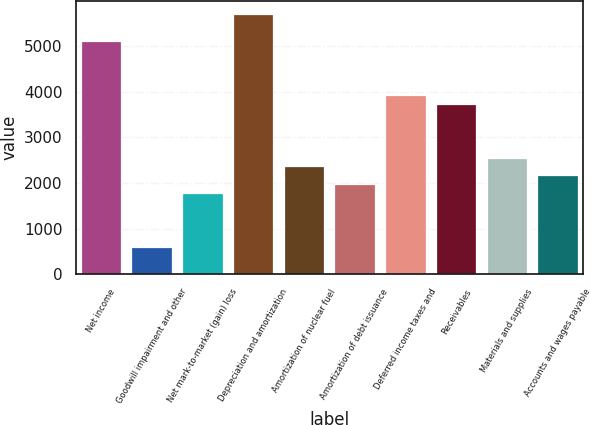<chart> <loc_0><loc_0><loc_500><loc_500><bar_chart><fcel>Net income<fcel>Goodwill impairment and other<fcel>Net mark-to-market (gain) loss<fcel>Depreciation and amortization<fcel>Amortization of nuclear fuel<fcel>Amortization of debt issuance<fcel>Deferred income taxes and<fcel>Receivables<fcel>Materials and supplies<fcel>Accounts and wages payable<nl><fcel>5112.6<fcel>590.8<fcel>1770.4<fcel>5702.4<fcel>2360.2<fcel>1967<fcel>3933<fcel>3736.4<fcel>2556.8<fcel>2163.6<nl></chart> 